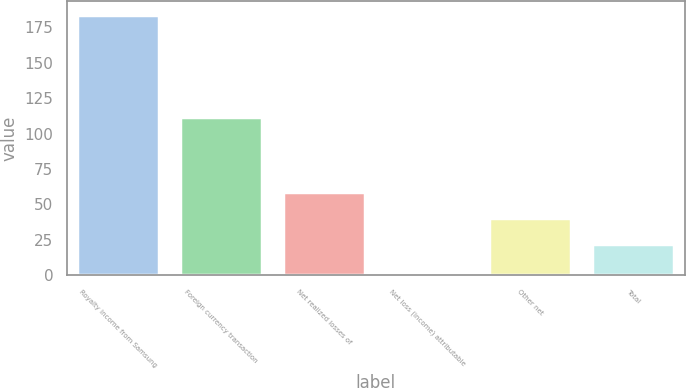Convert chart. <chart><loc_0><loc_0><loc_500><loc_500><bar_chart><fcel>Royalty income from Samsung<fcel>Foreign currency transaction<fcel>Net realized losses of<fcel>Net loss (income) attributable<fcel>Other net<fcel>Total<nl><fcel>184<fcel>112<fcel>58.6<fcel>1<fcel>40.3<fcel>22<nl></chart> 